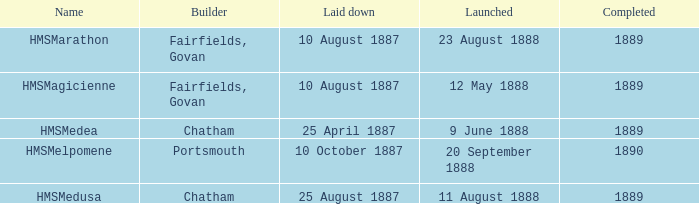Which builder completed after 1889? Portsmouth. Help me parse the entirety of this table. {'header': ['Name', 'Builder', 'Laid down', 'Launched', 'Completed'], 'rows': [['HMSMarathon', 'Fairfields, Govan', '10 August 1887', '23 August 1888', '1889'], ['HMSMagicienne', 'Fairfields, Govan', '10 August 1887', '12 May 1888', '1889'], ['HMSMedea', 'Chatham', '25 April 1887', '9 June 1888', '1889'], ['HMSMelpomene', 'Portsmouth', '10 October 1887', '20 September 1888', '1890'], ['HMSMedusa', 'Chatham', '25 August 1887', '11 August 1888', '1889']]} 